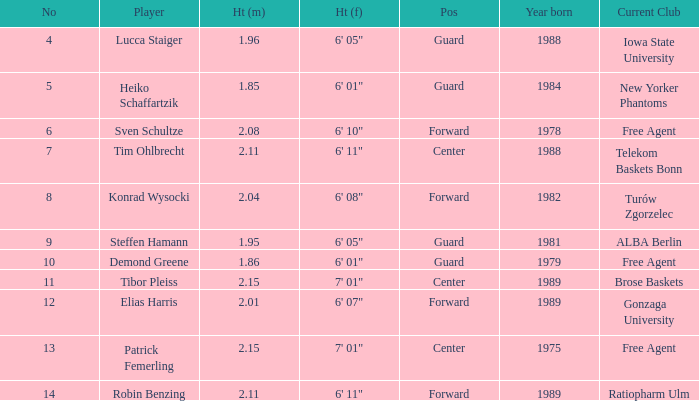State the height for the sportsperson born in 1989 who is 6' 11". 